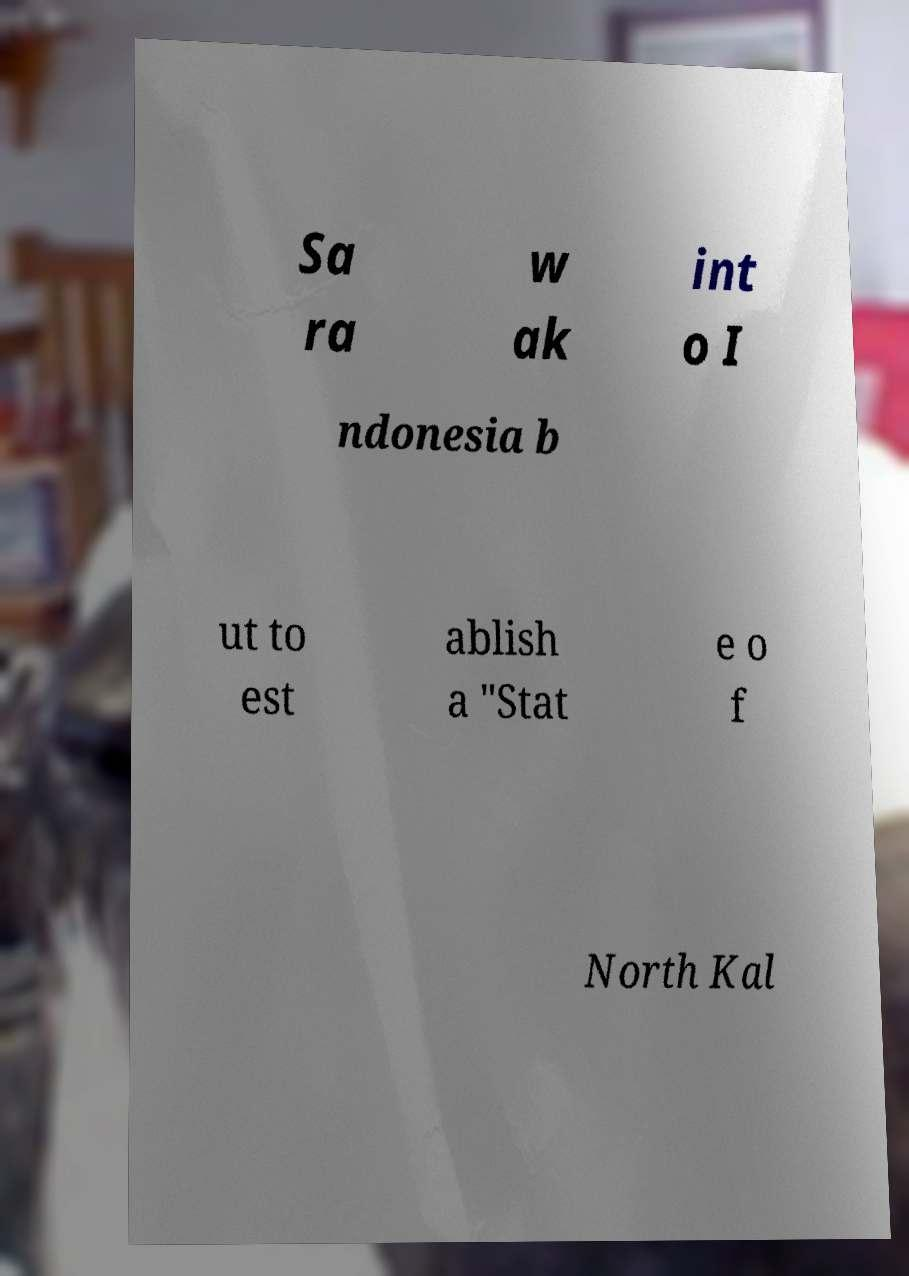For documentation purposes, I need the text within this image transcribed. Could you provide that? Sa ra w ak int o I ndonesia b ut to est ablish a "Stat e o f North Kal 